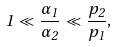Convert formula to latex. <formula><loc_0><loc_0><loc_500><loc_500>1 \ll \frac { \alpha _ { 1 } } { \alpha _ { 2 } } \ll \frac { p _ { 2 } } { p _ { 1 } } ,</formula> 